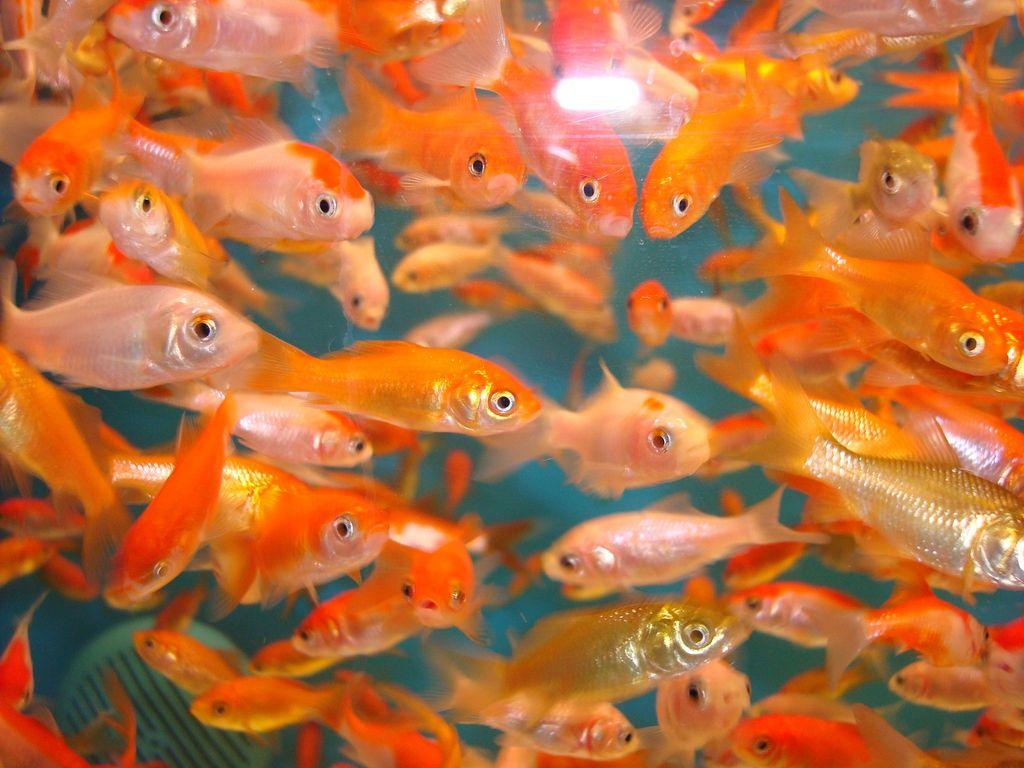What colors of fishes can be seen in the water? There are white, orange, and golden color fishes in the water. Can you describe the variety of fishes in the image? The image shows three different colors of fishes: white, orange, and golden. How many tomatoes are floating in the water with the fishes? There are no tomatoes present in the image; it only features fishes in the water. 